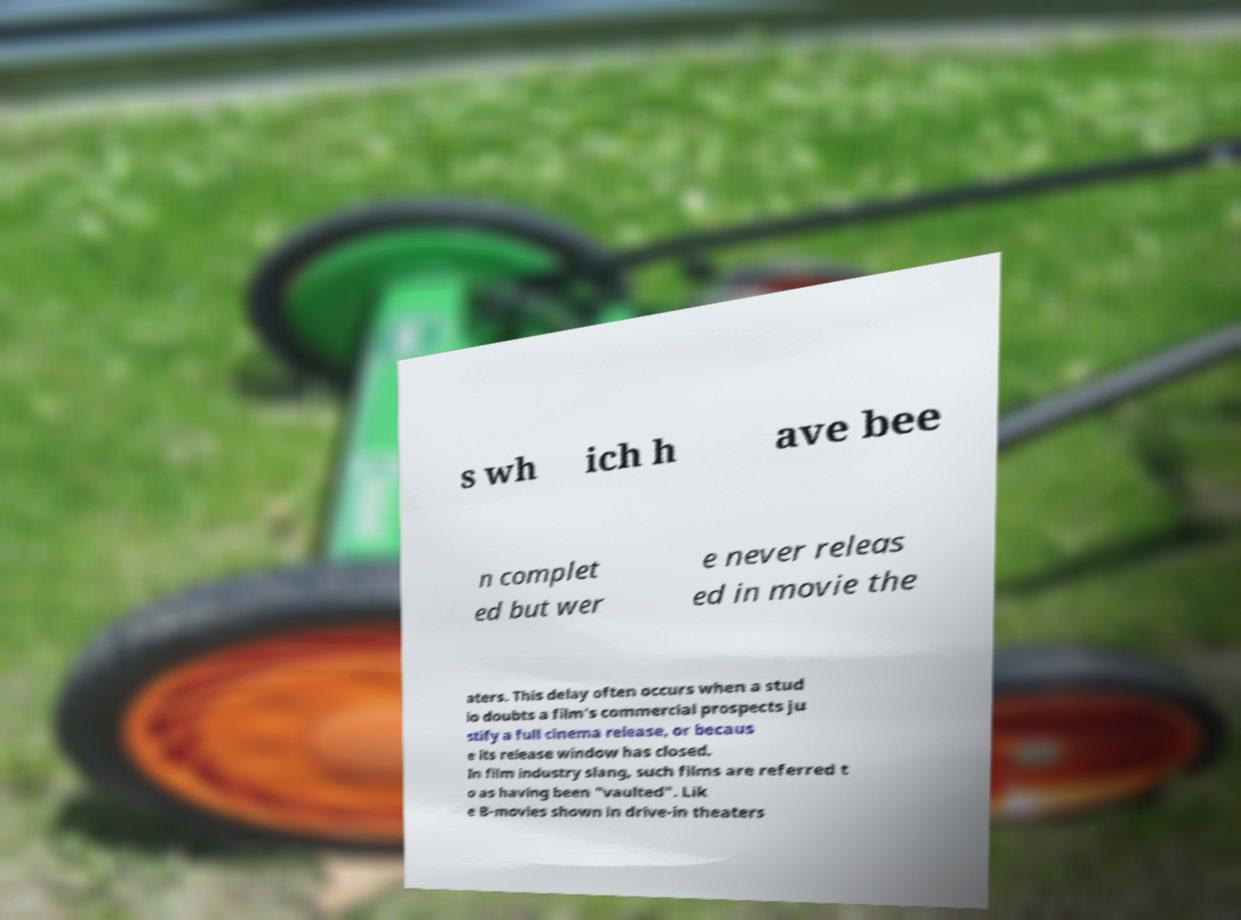For documentation purposes, I need the text within this image transcribed. Could you provide that? s wh ich h ave bee n complet ed but wer e never releas ed in movie the aters. This delay often occurs when a stud io doubts a film's commercial prospects ju stify a full cinema release, or becaus e its release window has closed. In film industry slang, such films are referred t o as having been "vaulted". Lik e B-movies shown in drive-in theaters 